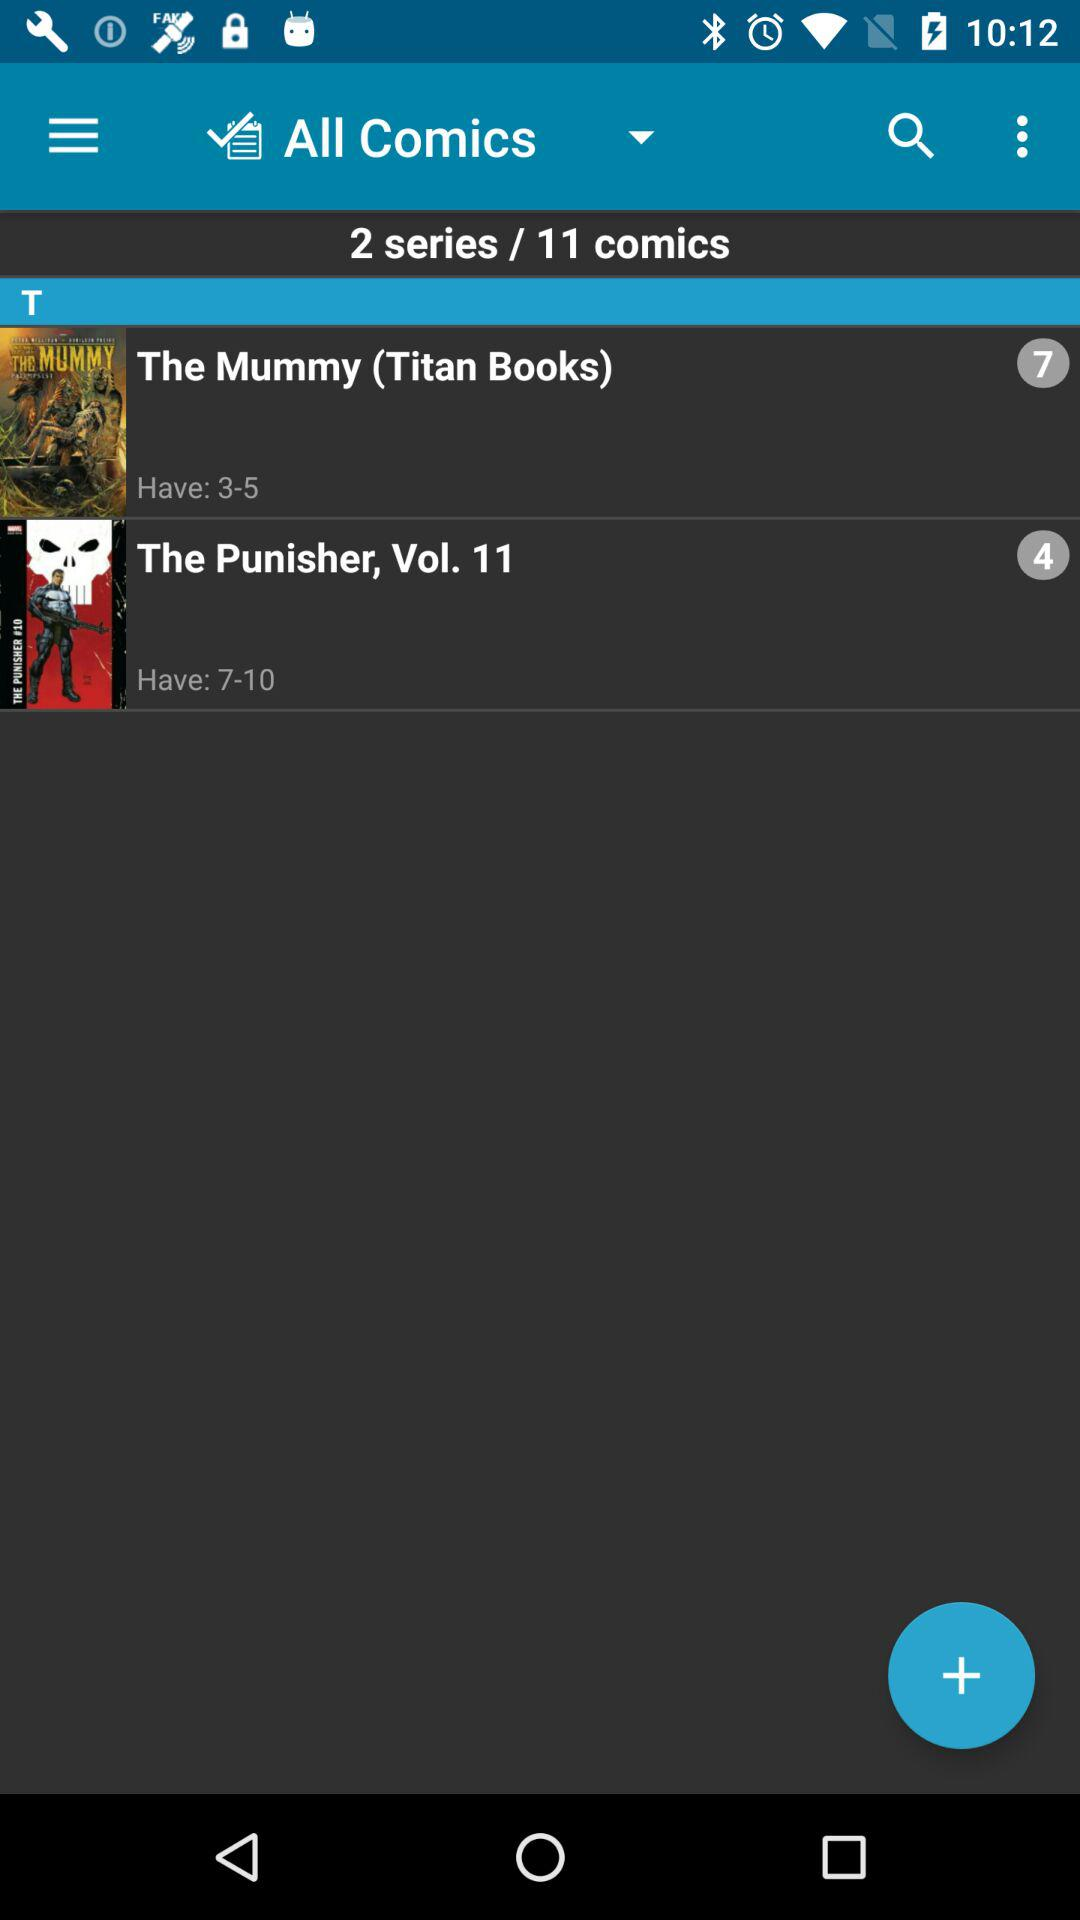What is the volume number? The volume number is 11. 